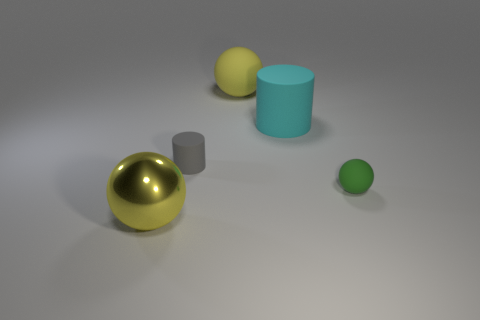Subtract all green rubber balls. How many balls are left? 2 Add 4 small yellow metallic balls. How many objects exist? 9 Subtract all green spheres. How many spheres are left? 2 Subtract all spheres. How many objects are left? 2 Subtract all yellow blocks. How many blue cylinders are left? 0 Subtract 2 cylinders. How many cylinders are left? 0 Subtract all green cylinders. Subtract all blue blocks. How many cylinders are left? 2 Subtract all green matte spheres. Subtract all tiny green rubber balls. How many objects are left? 3 Add 1 yellow objects. How many yellow objects are left? 3 Add 2 large yellow metal objects. How many large yellow metal objects exist? 3 